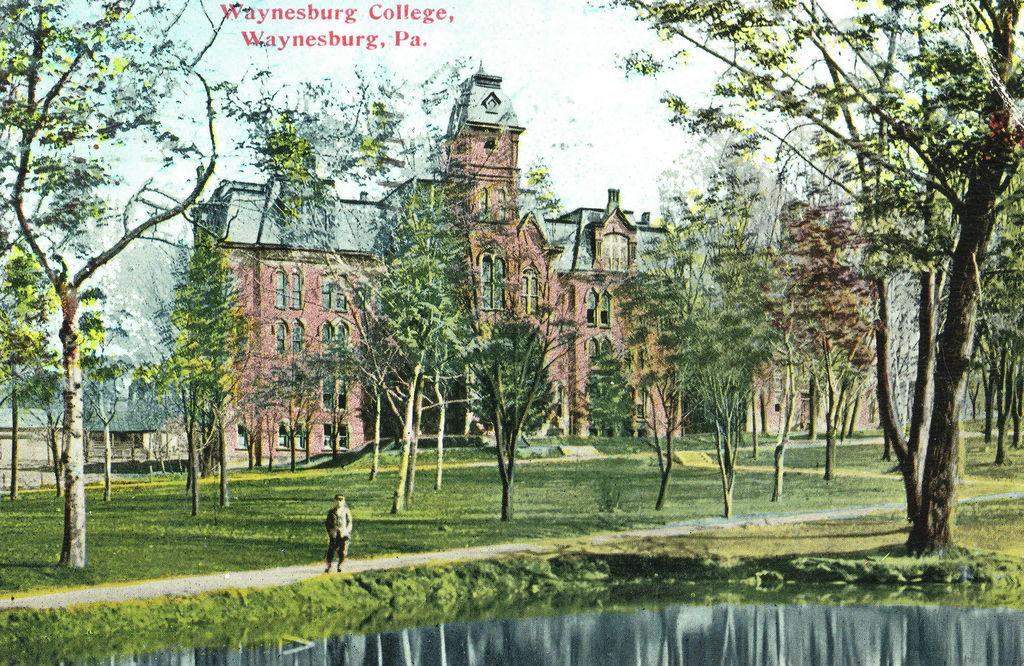Please provide a concise description of this image. As we can see in the image there is water, grass, a person standing over here, trees, buildings and sky. 